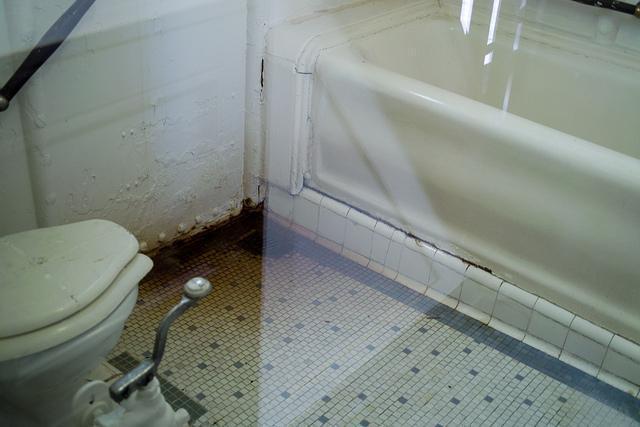How many men are standing in the bed of the truck?
Give a very brief answer. 0. 